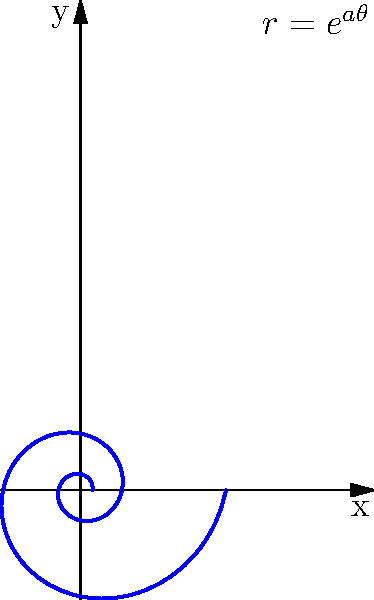The spiral pattern of a nautilus shell can be modeled using the polar equation $r = e^{a\theta}$, where $a$ is a constant determining the rate of growth. If the radius of the shell doubles every complete revolution, what is the value of $a$? To solve this problem, let's follow these steps:

1) In the equation $r = e^{a\theta}$, $r$ represents the radius and $\theta$ represents the angle in radians.

2) We know that one complete revolution is equal to $2\pi$ radians.

3) Let's say the initial radius is $r_1$ at $\theta = 0$, and the radius after one revolution is $r_2$ at $\theta = 2\pi$.

4) We're told that the radius doubles after one revolution, so $r_2 = 2r_1$.

5) Let's apply the equation to both cases:
   At $\theta = 0$: $r_1 = e^{a(0)} = 1$
   At $\theta = 2\pi$: $r_2 = e^{a(2\pi)} = 2r_1 = 2$

6) Now we can set up an equation:
   $e^{a(2\pi)} = 2$

7) Taking the natural log of both sides:
   $a(2\pi) = \ln(2)$

8) Solving for $a$:
   $a = \frac{\ln(2)}{2\pi}$

9) This can be simplified to:
   $a = \frac{\ln(2)}{2\pi} \approx 0.1103$

Therefore, the value of $a$ that causes the radius to double every revolution is approximately 0.1103.
Answer: $a = \frac{\ln(2)}{2\pi} \approx 0.1103$ 